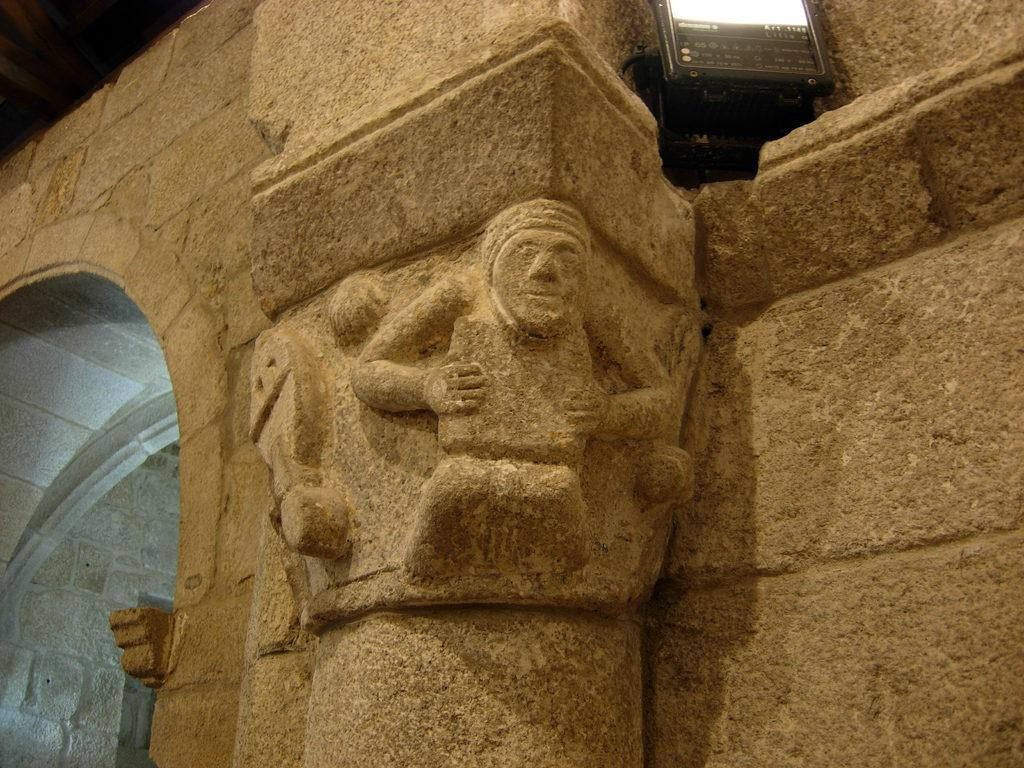What is the main subject in the center of the image? There is a sculpture in the center of the image. What can be seen at the top of the image? Light is visible at the top of the image. What is located on the left side of the image? There is a wall on the left side of the image. What type of collar can be seen on the grass in the image? There is no collar or grass present in the image. 